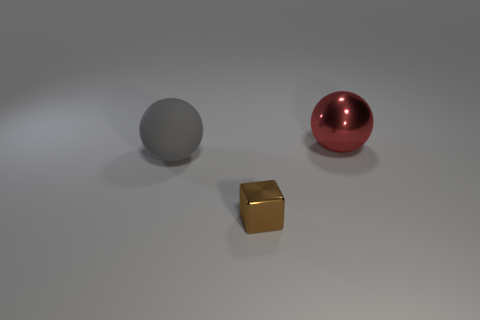Is the brown object made of the same material as the red thing?
Ensure brevity in your answer.  Yes. There is a big gray rubber ball; are there any spheres in front of it?
Offer a terse response. No. There is a tiny brown block left of the object that is behind the big gray thing; what is it made of?
Offer a terse response. Metal. There is a object that is both right of the matte ball and to the left of the large red shiny sphere; what color is it?
Make the answer very short. Brown. There is a shiny object behind the rubber ball; does it have the same size as the rubber object?
Provide a short and direct response. Yes. Is there anything else that is the same shape as the brown thing?
Keep it short and to the point. No. Do the red ball and the ball that is left of the metal sphere have the same material?
Make the answer very short. No. What number of blue things are either small metallic blocks or large rubber cylinders?
Your answer should be very brief. 0. Are any tiny green cubes visible?
Your answer should be very brief. No. There is a object that is behind the big thing to the left of the red shiny ball; is there a large object in front of it?
Provide a short and direct response. Yes. 